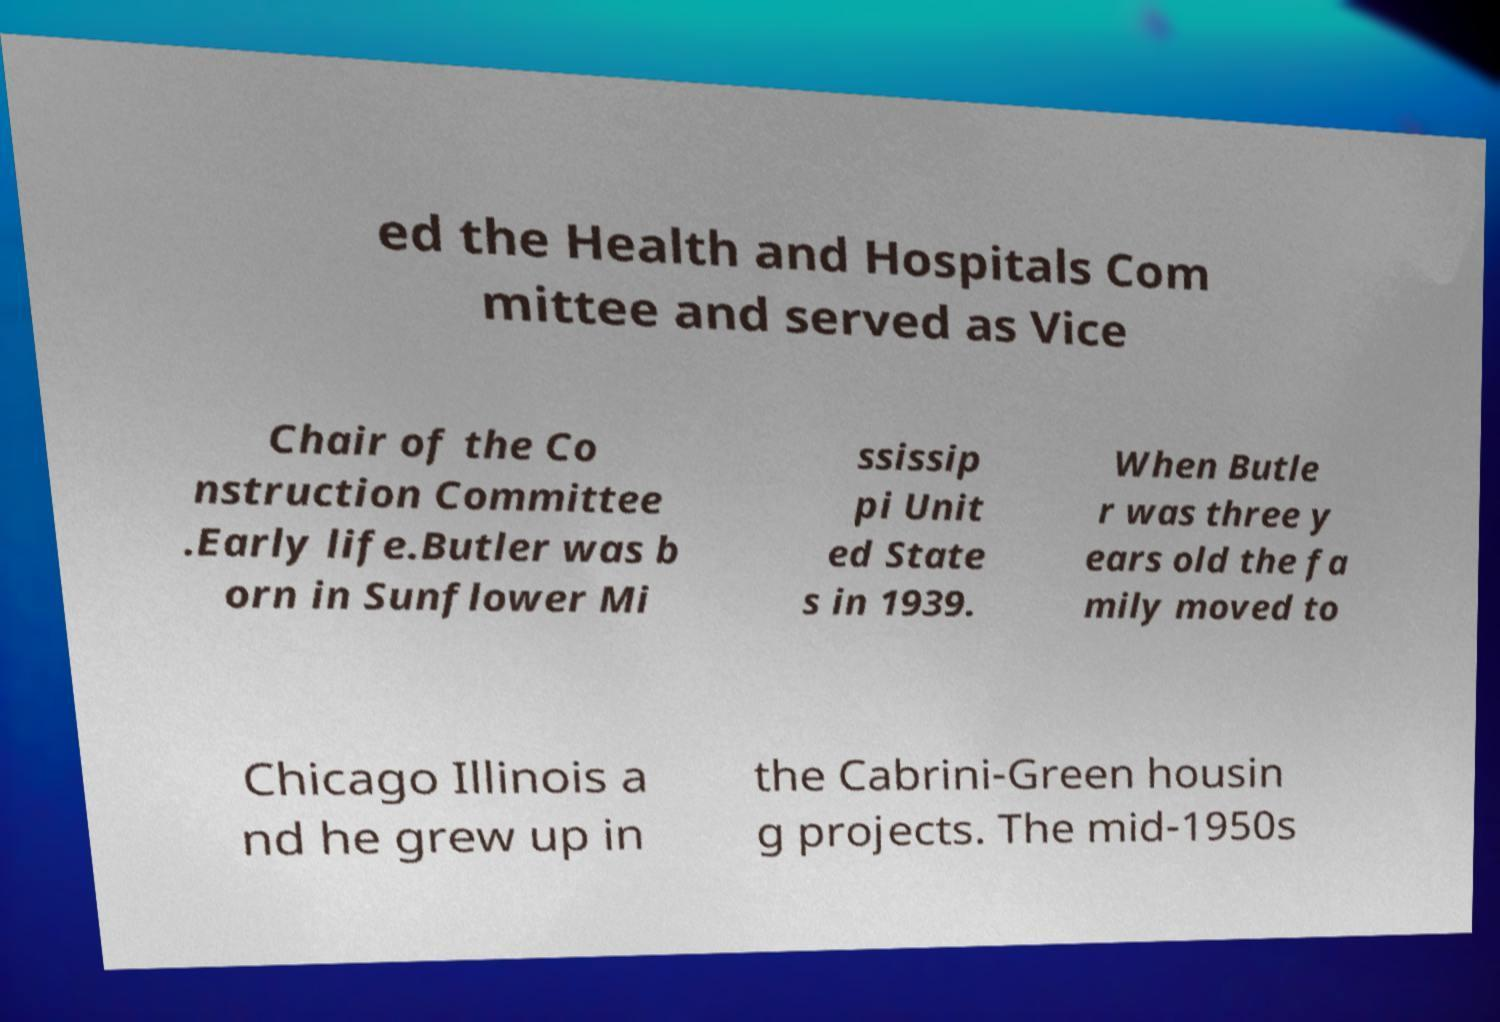Could you assist in decoding the text presented in this image and type it out clearly? ed the Health and Hospitals Com mittee and served as Vice Chair of the Co nstruction Committee .Early life.Butler was b orn in Sunflower Mi ssissip pi Unit ed State s in 1939. When Butle r was three y ears old the fa mily moved to Chicago Illinois a nd he grew up in the Cabrini-Green housin g projects. The mid-1950s 